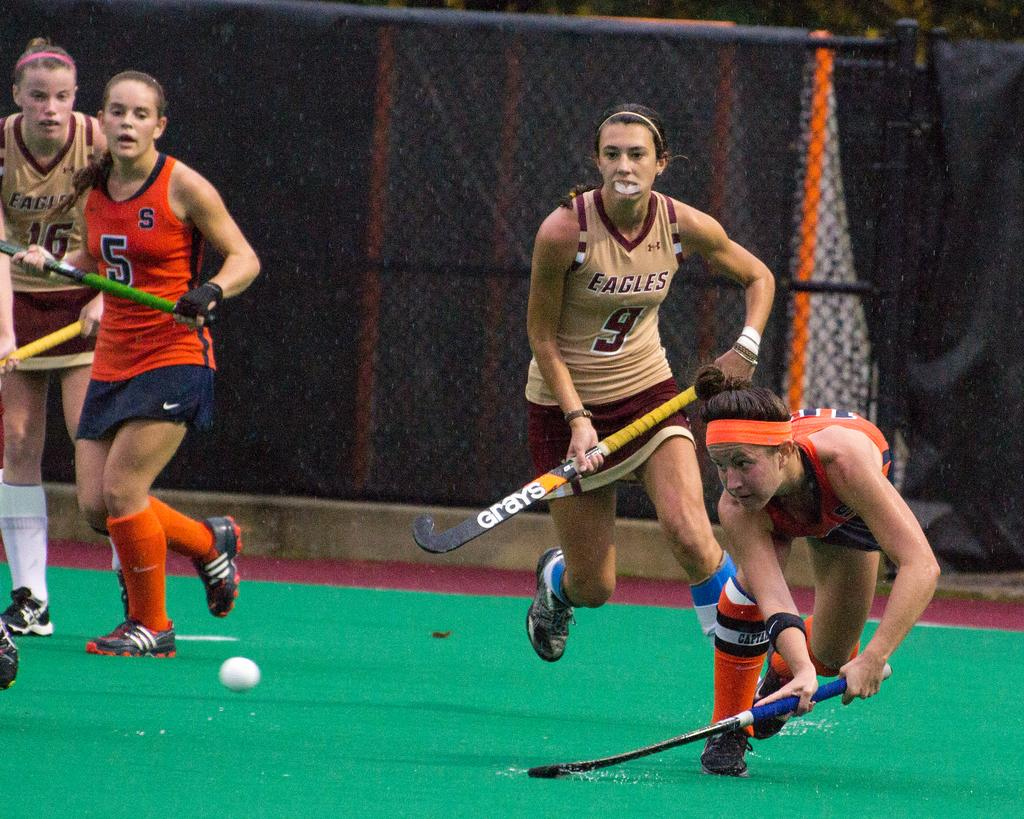<image>
Write a terse but informative summary of the picture. The woman's Eagles field hockey team is playing against a team in red. 